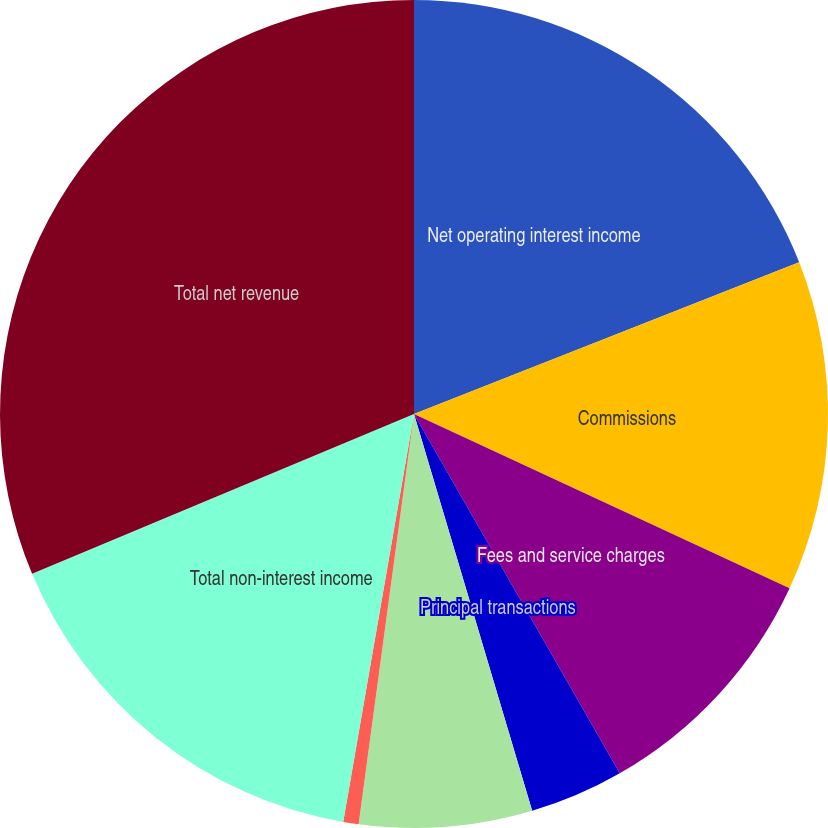<chart> <loc_0><loc_0><loc_500><loc_500><pie_chart><fcel>Net operating interest income<fcel>Commissions<fcel>Fees and service charges<fcel>Principal transactions<fcel>Gains on loans and securities<fcel>Other revenues<fcel>Total non-interest income<fcel>Total net revenue<nl><fcel>19.02%<fcel>12.88%<fcel>9.81%<fcel>3.67%<fcel>6.74%<fcel>0.6%<fcel>15.95%<fcel>31.3%<nl></chart> 